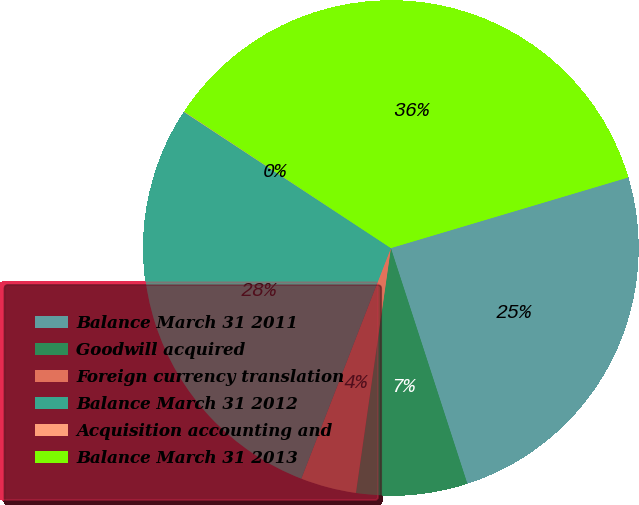<chart> <loc_0><loc_0><loc_500><loc_500><pie_chart><fcel>Balance March 31 2011<fcel>Goodwill acquired<fcel>Foreign currency translation<fcel>Balance March 31 2012<fcel>Acquisition accounting and<fcel>Balance March 31 2013<nl><fcel>24.61%<fcel>7.25%<fcel>3.64%<fcel>28.37%<fcel>0.03%<fcel>36.11%<nl></chart> 